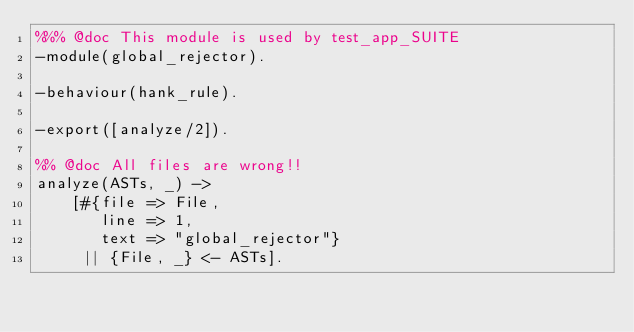<code> <loc_0><loc_0><loc_500><loc_500><_Erlang_>%%% @doc This module is used by test_app_SUITE
-module(global_rejector).

-behaviour(hank_rule).

-export([analyze/2]).

%% @doc All files are wrong!!
analyze(ASTs, _) ->
    [#{file => File,
       line => 1,
       text => "global_rejector"}
     || {File, _} <- ASTs].
</code> 